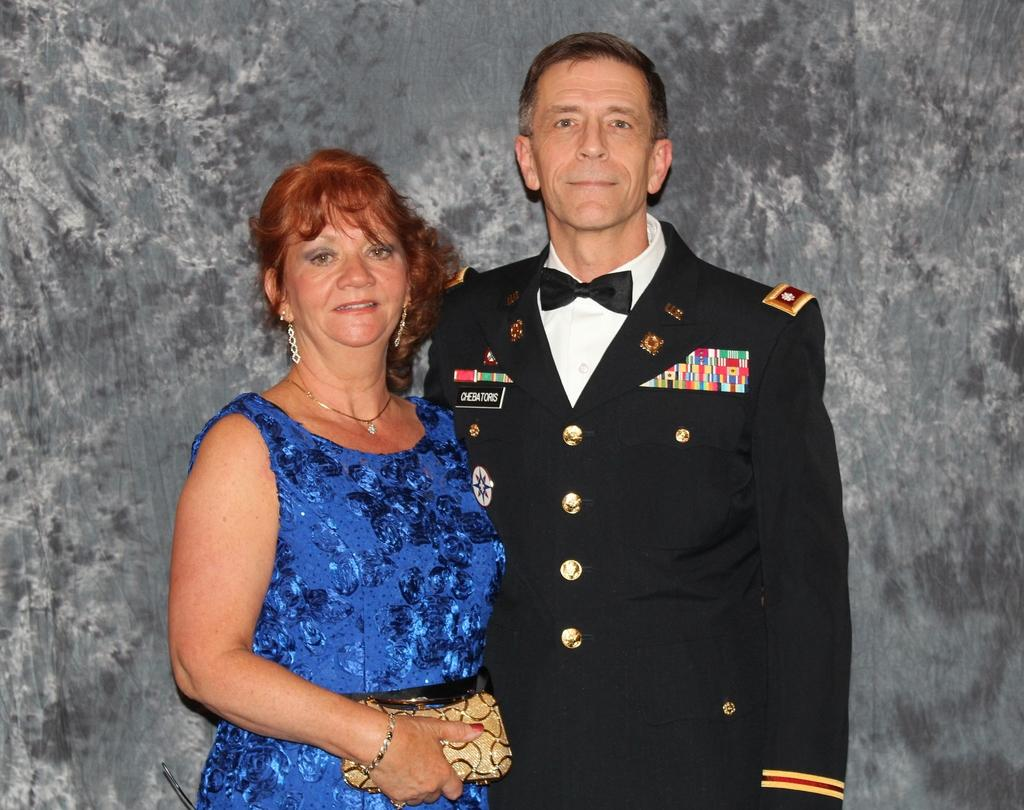How many people are in the image? There are two persons in the image. What can be observed about the background of the image? The background of the image is gray. Where is the person located on the left side of the image? The person on the left side of the image is holding a money bag with her hand. What type of tin can be seen in the image? There is no tin present in the image. Is the queen visible in the image? There is no queen present in the image. 